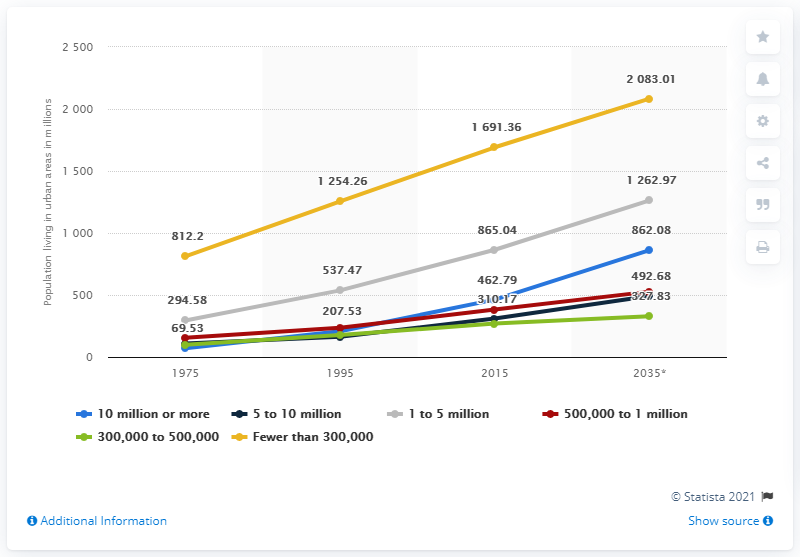Give some essential details in this illustration. By 2035, it is projected that approximately 812.2 million people worldwide will live in urban areas with populations of 10 million or more. 